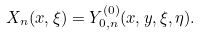<formula> <loc_0><loc_0><loc_500><loc_500>X _ { n } ( x , \xi ) = Y ^ { ( 0 ) } _ { 0 , n } ( x , y , \xi , \eta ) .</formula> 